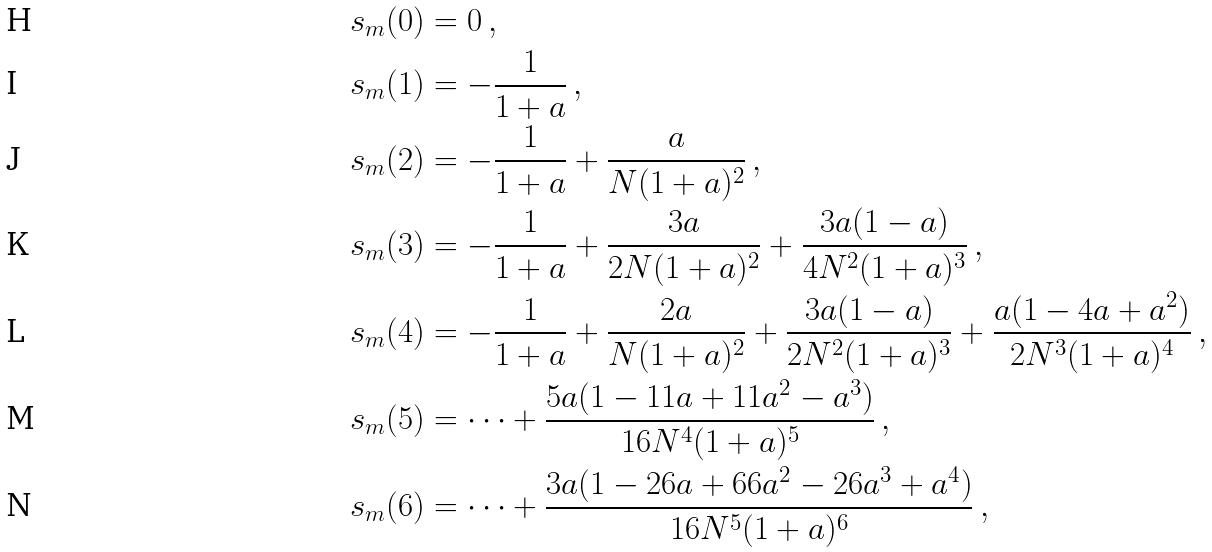<formula> <loc_0><loc_0><loc_500><loc_500>s _ { m } ( 0 ) & = 0 \, , \\ s _ { m } ( 1 ) & = - \frac { 1 } { 1 + a } \, , \\ s _ { m } ( 2 ) & = - \frac { 1 } { 1 + a } + \frac { a } { N ( 1 + a ) ^ { 2 } } \, , \\ s _ { m } ( 3 ) & = - \frac { 1 } { 1 + a } + \frac { 3 a } { 2 N ( 1 + a ) ^ { 2 } } + \frac { 3 a ( 1 - a ) } { 4 N ^ { 2 } ( 1 + a ) ^ { 3 } } \, , \\ s _ { m } ( 4 ) & = - \frac { 1 } { 1 + a } + \frac { 2 a } { N ( 1 + a ) ^ { 2 } } + \frac { 3 a ( 1 - a ) } { 2 N ^ { 2 } ( 1 + a ) ^ { 3 } } + \frac { a ( 1 - 4 a + a ^ { 2 } ) } { 2 N ^ { 3 } ( 1 + a ) ^ { 4 } } \, , \\ s _ { m } ( 5 ) & = \cdots + \frac { 5 a ( 1 - 1 1 a + 1 1 a ^ { 2 } - a ^ { 3 } ) } { 1 6 N ^ { 4 } ( 1 + a ) ^ { 5 } } \, , \\ s _ { m } ( 6 ) & = \cdots + \frac { 3 a ( 1 - 2 6 a + 6 6 a ^ { 2 } - 2 6 a ^ { 3 } + a ^ { 4 } ) } { 1 6 N ^ { 5 } ( 1 + a ) ^ { 6 } } \, ,</formula> 